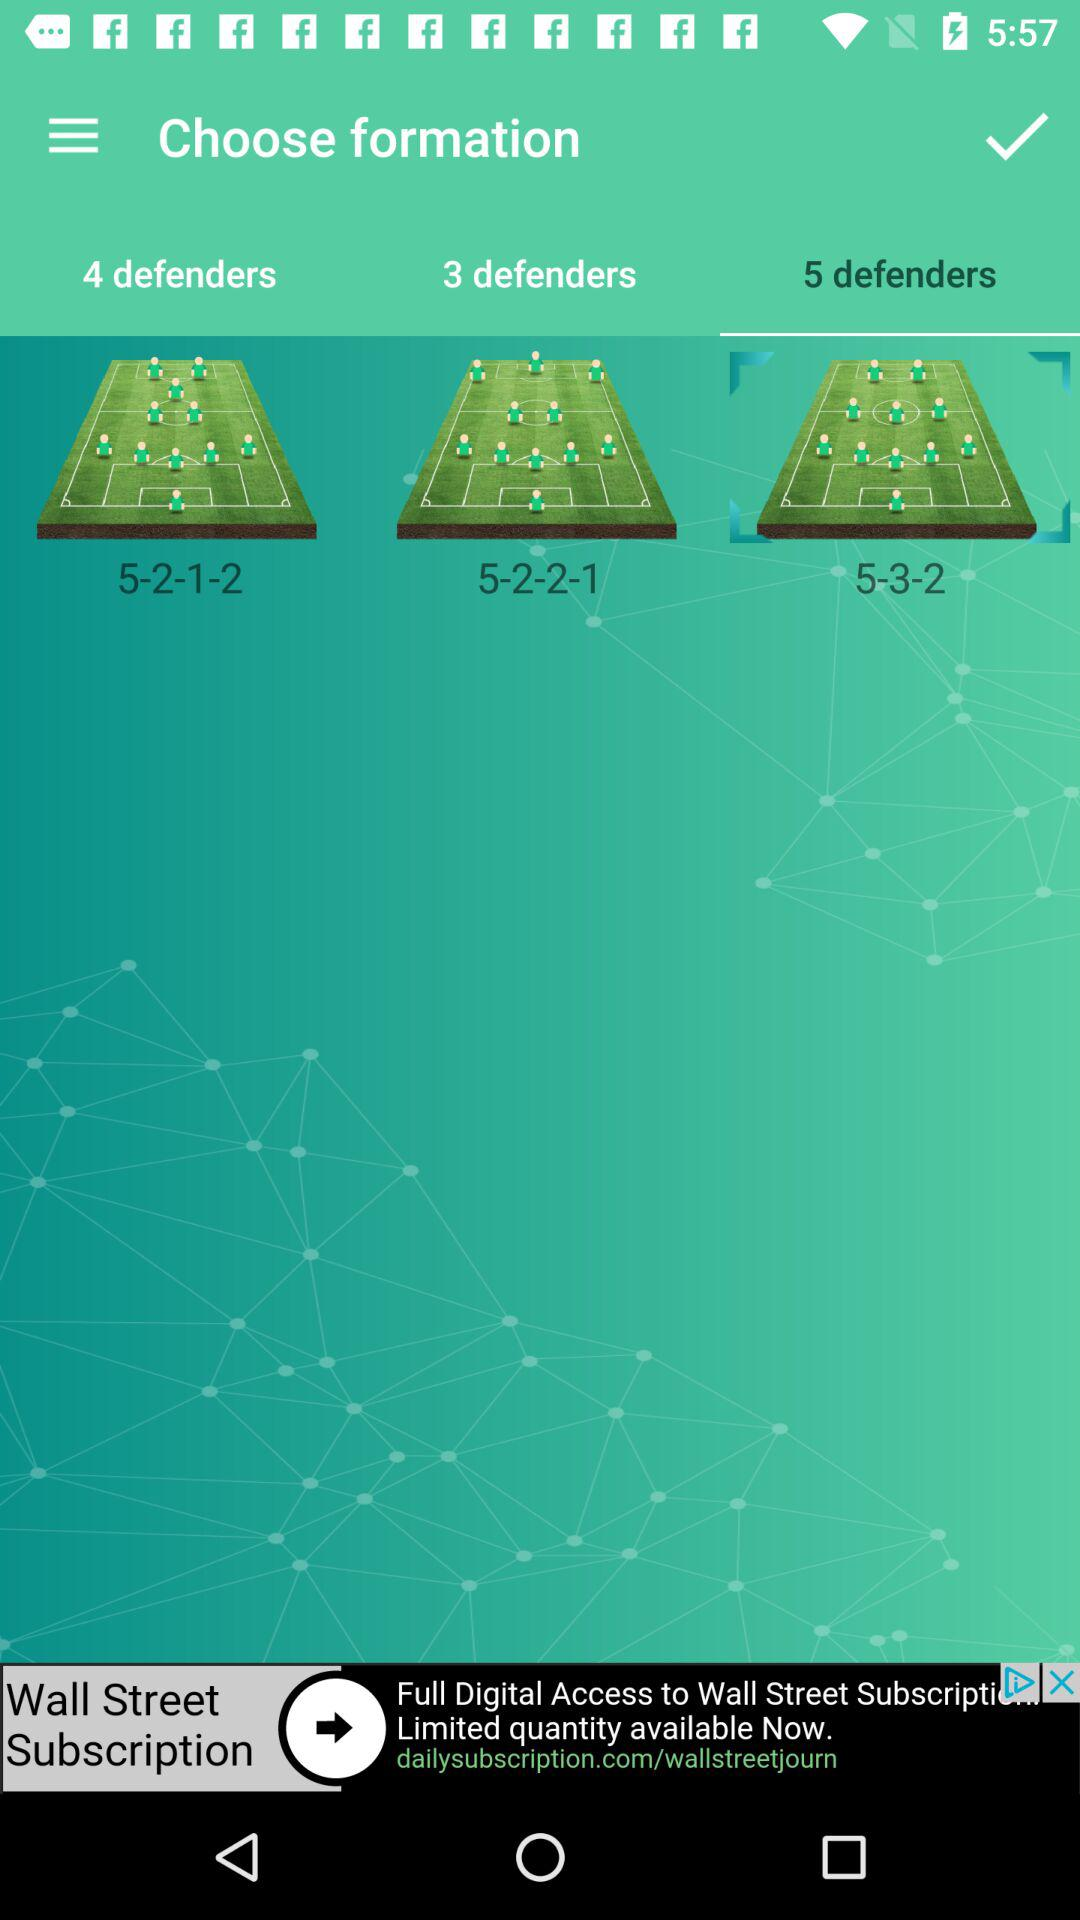How many defenders are there in the formation with the most number of defenders?
Answer the question using a single word or phrase. 5 